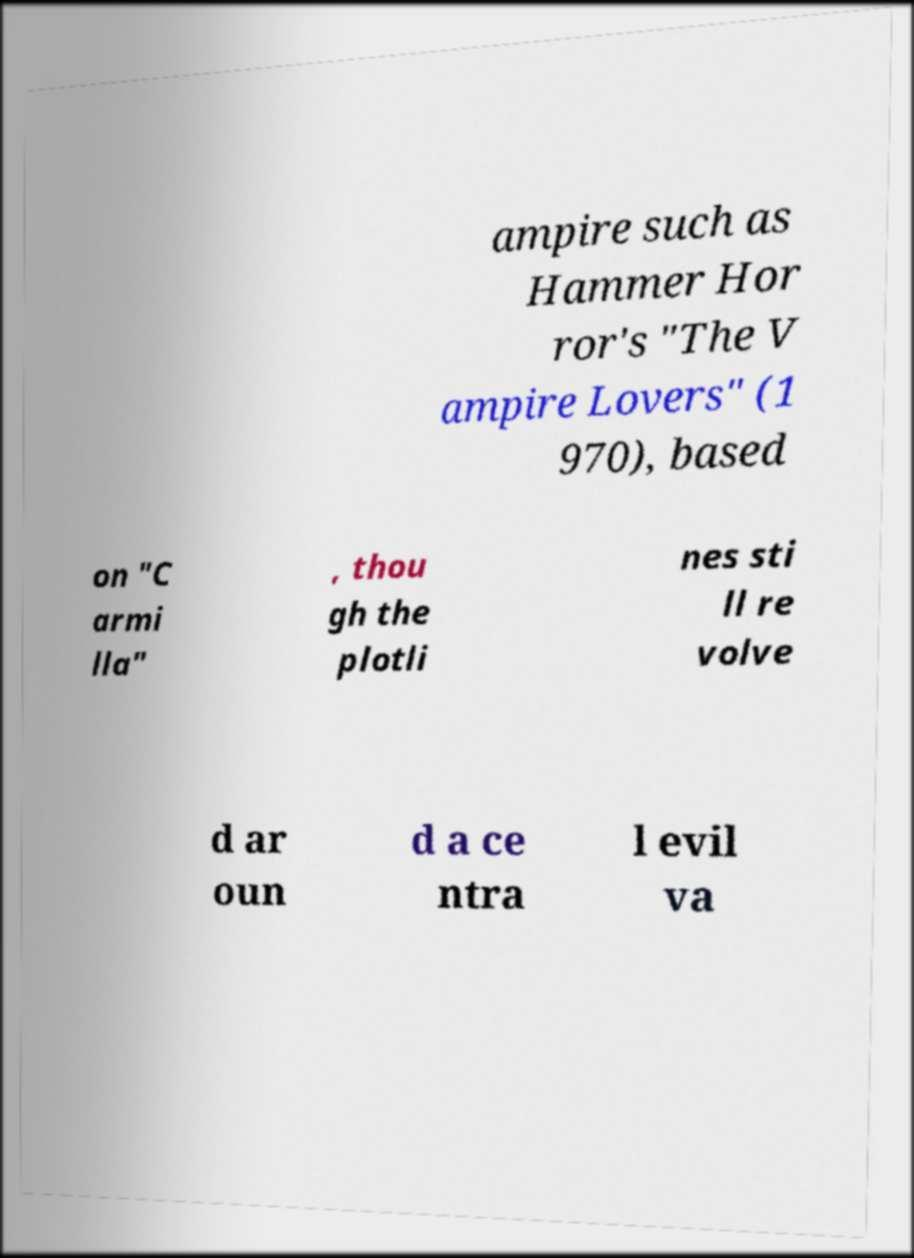Please read and relay the text visible in this image. What does it say? ampire such as Hammer Hor ror's "The V ampire Lovers" (1 970), based on "C armi lla" , thou gh the plotli nes sti ll re volve d ar oun d a ce ntra l evil va 